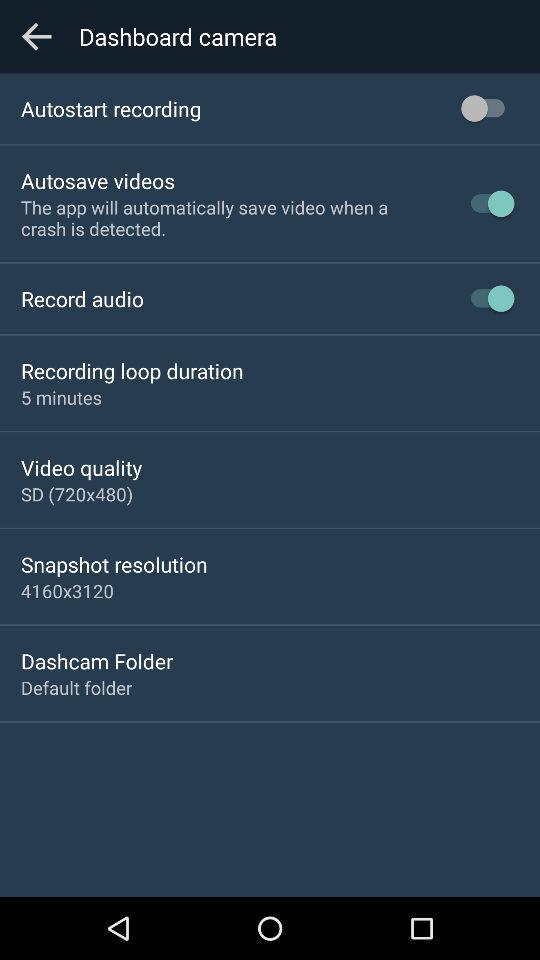What is the video quality? The video quality is "SD (720×480)". 